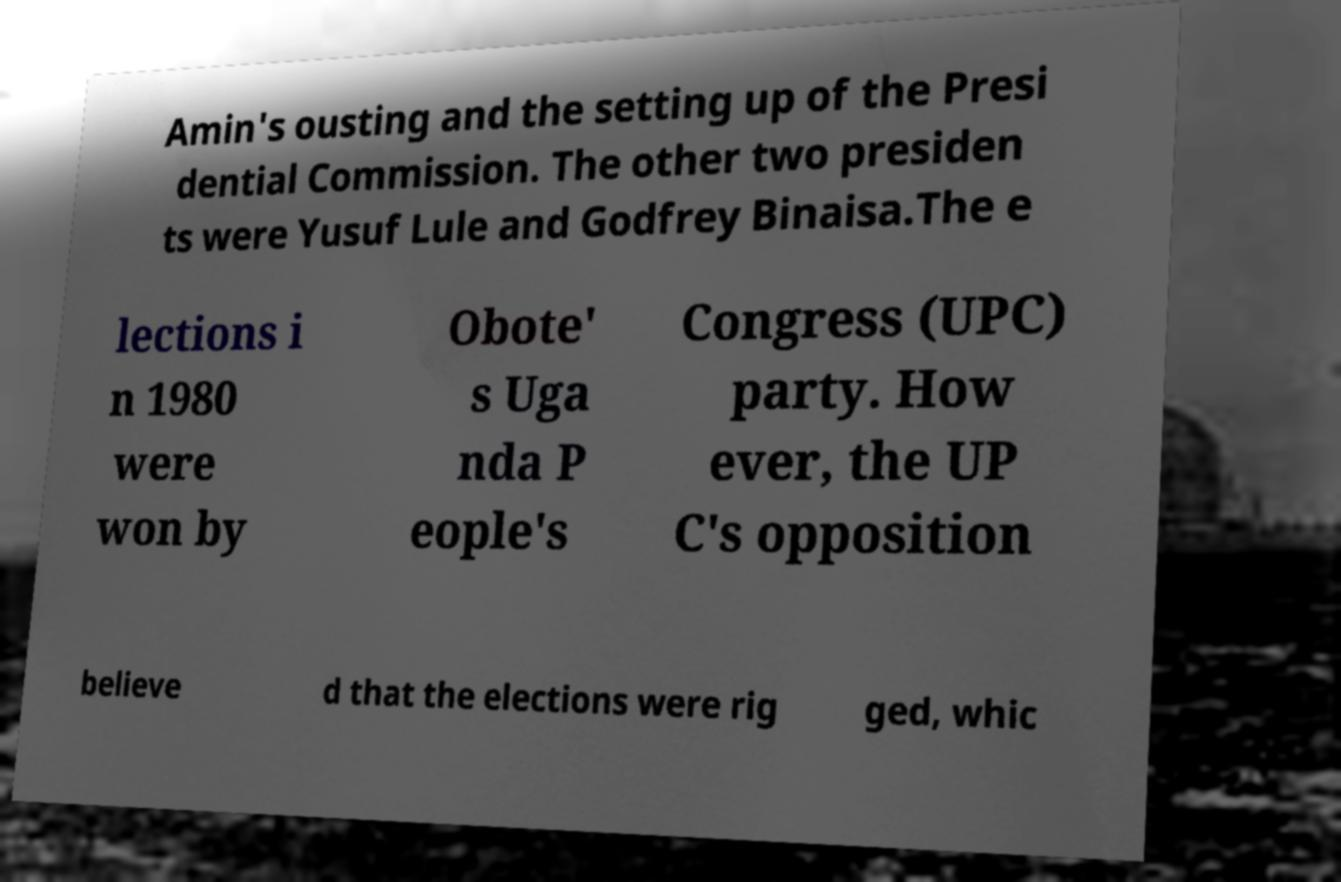Could you assist in decoding the text presented in this image and type it out clearly? Amin's ousting and the setting up of the Presi dential Commission. The other two presiden ts were Yusuf Lule and Godfrey Binaisa.The e lections i n 1980 were won by Obote' s Uga nda P eople's Congress (UPC) party. How ever, the UP C's opposition believe d that the elections were rig ged, whic 